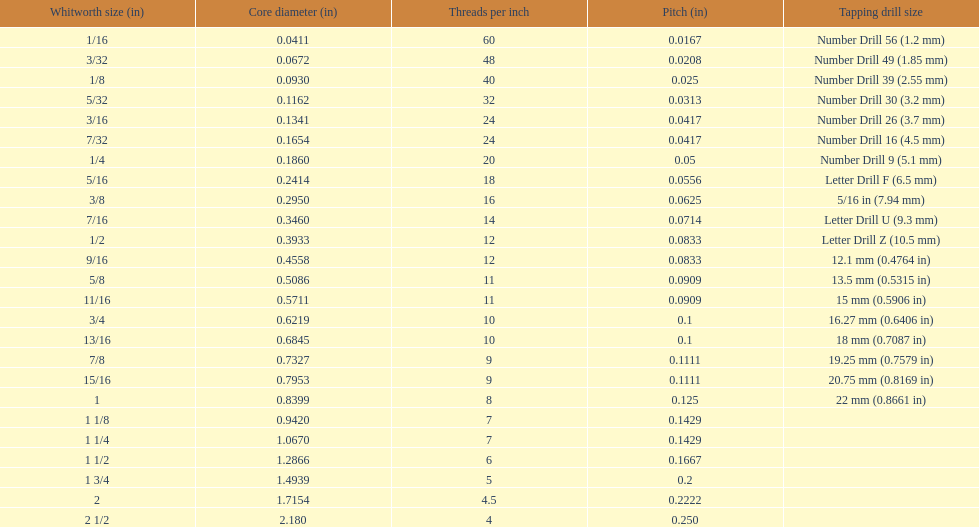Identify the preceding whitworth size (in) that is smaller than 1/ 5/32. Would you be able to parse every entry in this table? {'header': ['Whitworth size (in)', 'Core diameter (in)', 'Threads per\xa0inch', 'Pitch (in)', 'Tapping drill size'], 'rows': [['1/16', '0.0411', '60', '0.0167', 'Number Drill 56 (1.2\xa0mm)'], ['3/32', '0.0672', '48', '0.0208', 'Number Drill 49 (1.85\xa0mm)'], ['1/8', '0.0930', '40', '0.025', 'Number Drill 39 (2.55\xa0mm)'], ['5/32', '0.1162', '32', '0.0313', 'Number Drill 30 (3.2\xa0mm)'], ['3/16', '0.1341', '24', '0.0417', 'Number Drill 26 (3.7\xa0mm)'], ['7/32', '0.1654', '24', '0.0417', 'Number Drill 16 (4.5\xa0mm)'], ['1/4', '0.1860', '20', '0.05', 'Number Drill 9 (5.1\xa0mm)'], ['5/16', '0.2414', '18', '0.0556', 'Letter Drill F (6.5\xa0mm)'], ['3/8', '0.2950', '16', '0.0625', '5/16\xa0in (7.94\xa0mm)'], ['7/16', '0.3460', '14', '0.0714', 'Letter Drill U (9.3\xa0mm)'], ['1/2', '0.3933', '12', '0.0833', 'Letter Drill Z (10.5\xa0mm)'], ['9/16', '0.4558', '12', '0.0833', '12.1\xa0mm (0.4764\xa0in)'], ['5/8', '0.5086', '11', '0.0909', '13.5\xa0mm (0.5315\xa0in)'], ['11/16', '0.5711', '11', '0.0909', '15\xa0mm (0.5906\xa0in)'], ['3/4', '0.6219', '10', '0.1', '16.27\xa0mm (0.6406\xa0in)'], ['13/16', '0.6845', '10', '0.1', '18\xa0mm (0.7087\xa0in)'], ['7/8', '0.7327', '9', '0.1111', '19.25\xa0mm (0.7579\xa0in)'], ['15/16', '0.7953', '9', '0.1111', '20.75\xa0mm (0.8169\xa0in)'], ['1', '0.8399', '8', '0.125', '22\xa0mm (0.8661\xa0in)'], ['1 1/8', '0.9420', '7', '0.1429', ''], ['1 1/4', '1.0670', '7', '0.1429', ''], ['1 1/2', '1.2866', '6', '0.1667', ''], ['1 3/4', '1.4939', '5', '0.2', ''], ['2', '1.7154', '4.5', '0.2222', ''], ['2 1/2', '2.180', '4', '0.250', '']]} 